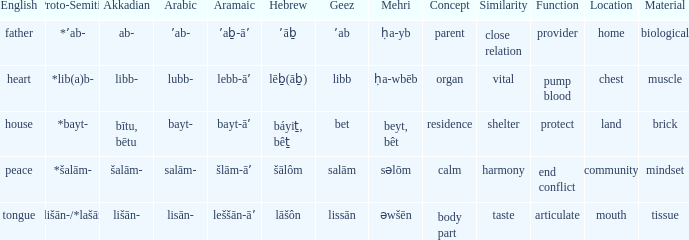Can you give me this table as a dict? {'header': ['English', 'Proto-Semitic', 'Akkadian', 'Arabic', 'Aramaic', 'Hebrew', 'Geez', 'Mehri', 'Concept', 'Similarity', 'Function', 'Location', 'Material'], 'rows': [['father', '*ʼab-', 'ab-', 'ʼab-', 'ʼaḇ-āʼ', 'ʼāḇ', 'ʼab', 'ḥa-yb', 'parent', 'close relation', 'provider', 'home', 'biological'], ['heart', '*lib(a)b-', 'libb-', 'lubb-', 'lebb-āʼ', 'lēḇ(āḇ)', 'libb', 'ḥa-wbēb', 'organ', 'vital', 'pump blood', 'chest', 'muscle'], ['house', '*bayt-', 'bītu, bētu', 'bayt-', 'bayt-āʼ', 'báyiṯ, bêṯ', 'bet', 'beyt, bêt', 'residence', 'shelter', 'protect', 'land', 'brick'], ['peace', '*šalām-', 'šalām-', 'salām-', 'šlām-āʼ', 'šālôm', 'salām', 'səlōm', 'calm', 'harmony', 'end conflict', 'community', 'mindset'], ['tongue', '*lišān-/*lašān-', 'lišān-', 'lisān-', 'leššān-āʼ', 'lāšôn', 'lissān', 'əwšēn', 'body part', 'taste', 'articulate', 'mouth', 'tissue']]} If the proto-semitic is *bayt-, what are the geez counterparts? Bet. 